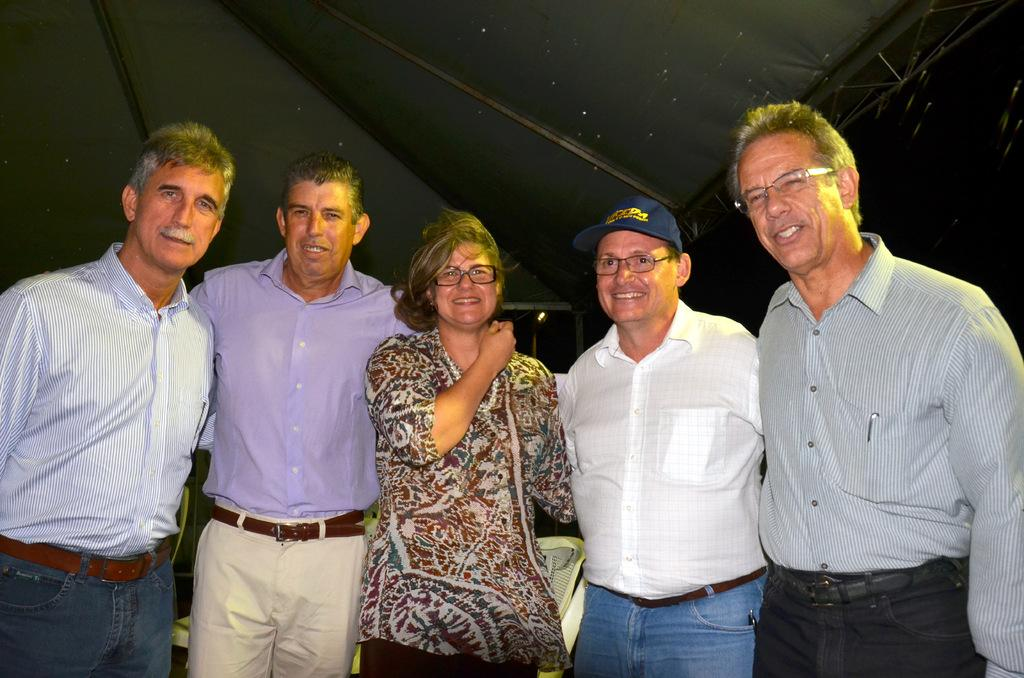What are the people in the image doing? The people in the image are standing side by side and smiling. What can be seen in the background of the image? In the background of the image, there are poles, a tent, a light, chairs, and a few unspecified things. How would you describe the lighting in the background of the image? The background view is dark. What type of bushes can be seen in the image? There are no bushes present in the image. Is there any sleet visible in the image? There is no mention of sleet in the image, and it is not visible. Can you tell me where the cannon is located in the image? There is no cannon present in the image. 